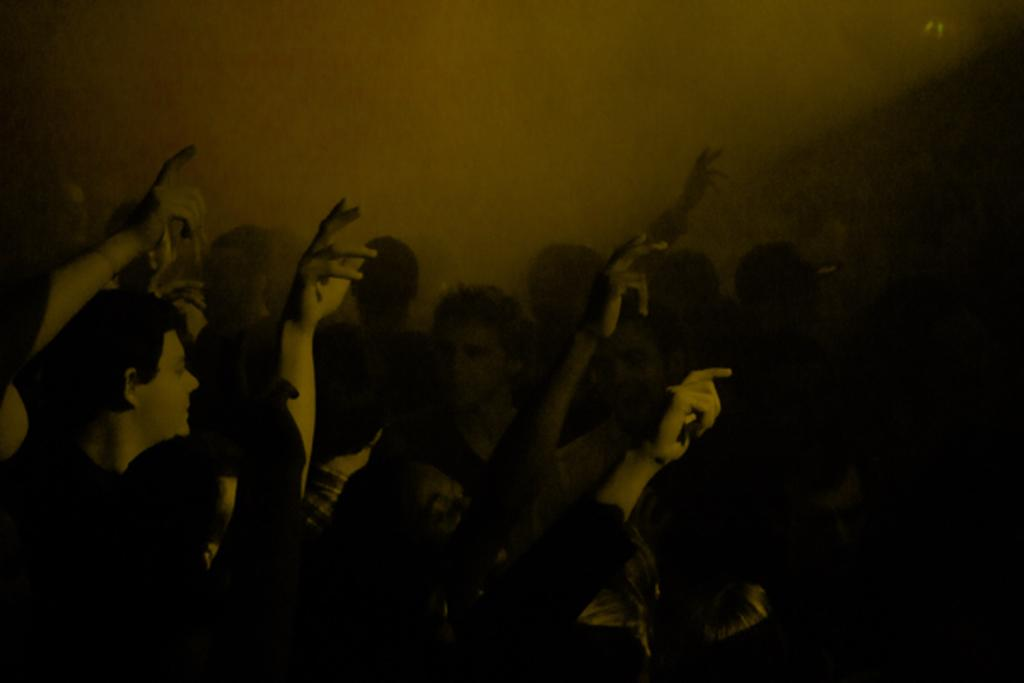How many individuals are present in the image? There are many people in the image. What are the people in the image doing? The people are dancing. What color scheme is used in the image? The image is black and white. Reasoning: Let'g: Let's think step by step in order to produce the conversation. We start by identifying the main subject of the image, which is the people. Then, we describe their actions, which are dancing. Finally, we mention the color scheme of the image, which is black and white. We ensure that each question can be answered definitively with the information given and avoid yes/no questions. Absurd Question/Answer: What type of letter is being delivered to the army on the trail in the image? There is no letter, army, or trail present in the image; it features many people dancing in a black and white setting. 